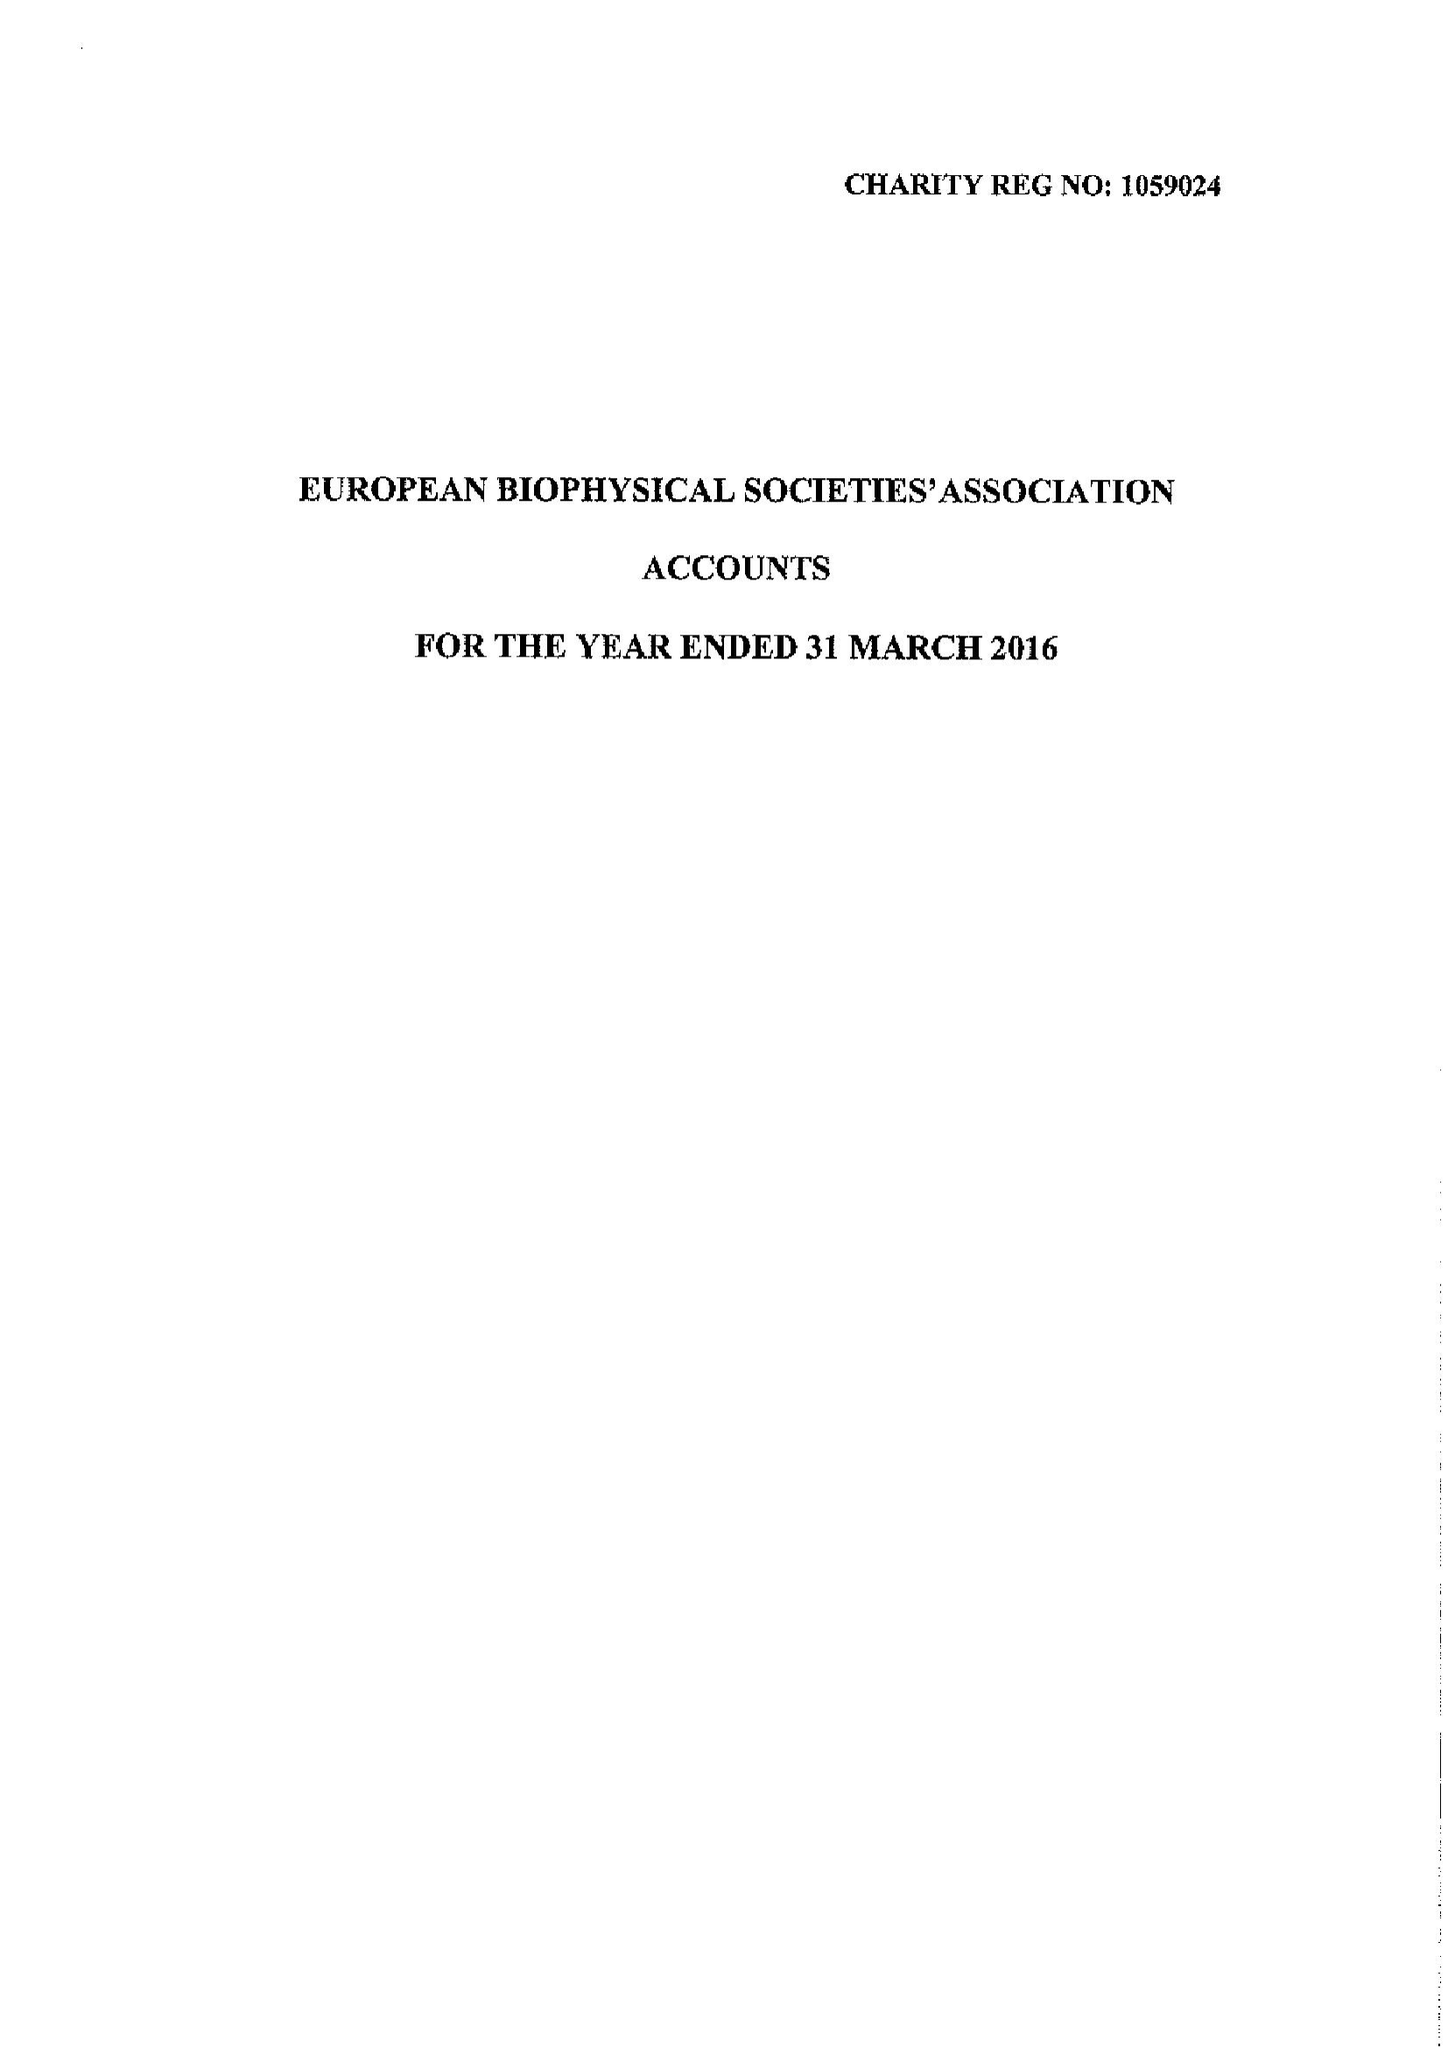What is the value for the charity_name?
Answer the question using a single word or phrase. The European Biophysical Societies' Association 